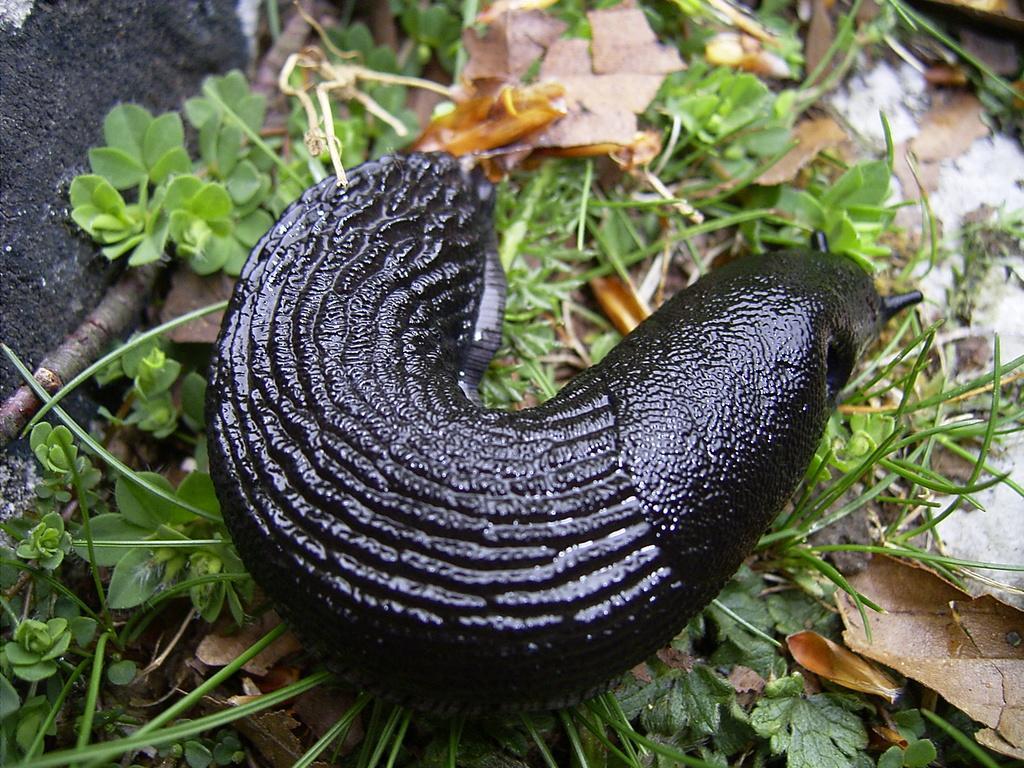Please provide a concise description of this image. In the center of the image we can see the snail. In the background of the image we can see the plants and dry leaves. On the left side of the image we can see the stone. 